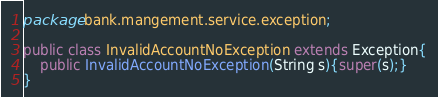<code> <loc_0><loc_0><loc_500><loc_500><_Java_>package bank.mangement.service.exception;

public class InvalidAccountNoException extends Exception{
    public InvalidAccountNoException(String s){super(s);}
}
</code> 